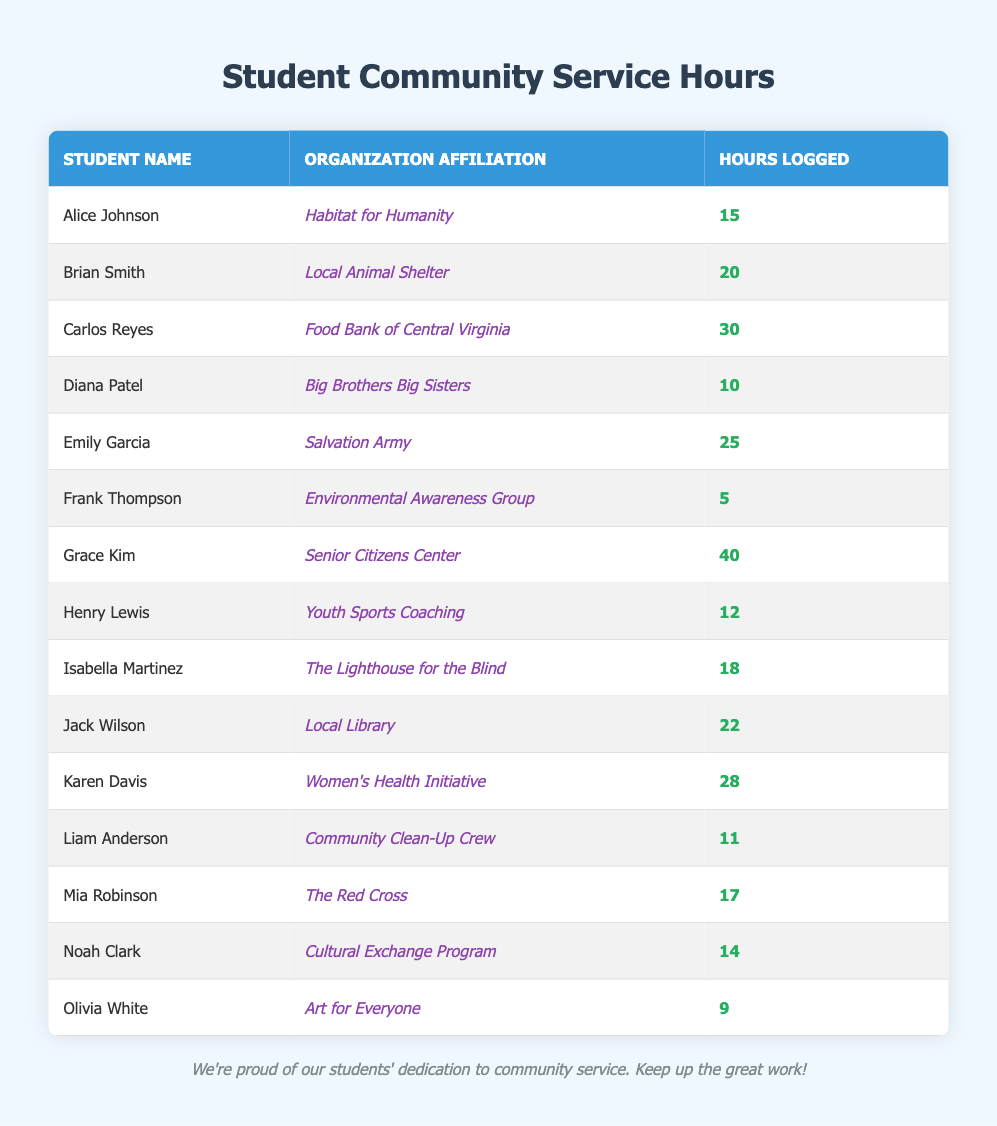What is the name of the student who logged the most community service hours? By reviewing the table, we can see that Grace Kim has logged 40 hours, which is the highest among all students.
Answer: Grace Kim Which organization did Carlos Reyes log hours for? The table clearly states that Carlos Reyes is affiliated with the Food Bank of Central Virginia for his community service.
Answer: Food Bank of Central Virginia How many hours did Emily Garcia log? The table shows that Emily Garcia logged a total of 25 hours.
Answer: 25 What is the total number of hours logged by students affiliated with the Women's Health Initiative? According to the table, Karen Davis is the only student affiliated with the Women's Health Initiative, and she logged 28 hours.
Answer: 28 What is the average number of hours logged by students in the Environmental Awareness Group? Frank Thompson is the only student in the Environmental Awareness Group, and he logged 5 hours. Therefore, the average is simply 5 hours.
Answer: 5 Did any student log fewer than 10 hours? The table shows Olivia White logged only 9 hours, which is indeed fewer than 10.
Answer: Yes Who logged more hours: Mia Robinson or Liam Anderson? Mia Robinson logged 17 hours, while Liam Anderson logged 11 hours. Since 17 is greater than 11, Mia logged more hours.
Answer: Mia Robinson What is the total number of community service hours logged by all students listed? Summing all the hours from the table: 15 + 20 + 30 + 10 + 25 + 5 + 40 + 12 + 18 + 22 + 28 + 11 + 17 + 14 + 9 =  335 hours in total.
Answer: 335 How many students logged over 20 hours? By examining the table, we see that Carlos Reyes, Emily Garcia, Jack Wilson, and Karen Davis logged more than 20 hours. This totals 4 students.
Answer: 4 If we consider only students affiliated with animal care or environmental causes, how many hours did they log in total? Brian Smith and Frank Thompson are affiliated with animal and environmental organizations, logging 20 and 5 hours, respectively. The total is thus 20 + 5 = 25 hours.
Answer: 25 Was there a student who logged exactly 15 hours? Yes, the table indicates that Alice Johnson logged exactly 15 hours of community service.
Answer: Yes 